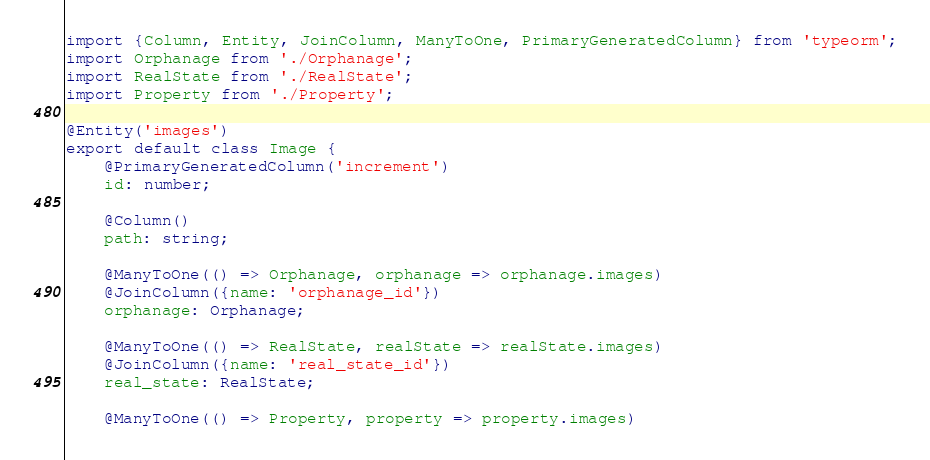<code> <loc_0><loc_0><loc_500><loc_500><_TypeScript_>import {Column, Entity, JoinColumn, ManyToOne, PrimaryGeneratedColumn} from 'typeorm';
import Orphanage from './Orphanage';
import RealState from './RealState';
import Property from './Property';

@Entity('images')
export default class Image {
    @PrimaryGeneratedColumn('increment')
    id: number;

    @Column()
    path: string;

    @ManyToOne(() => Orphanage, orphanage => orphanage.images)
    @JoinColumn({name: 'orphanage_id'})
    orphanage: Orphanage;

    @ManyToOne(() => RealState, realState => realState.images)
    @JoinColumn({name: 'real_state_id'})
    real_state: RealState;

    @ManyToOne(() => Property, property => property.images)</code> 